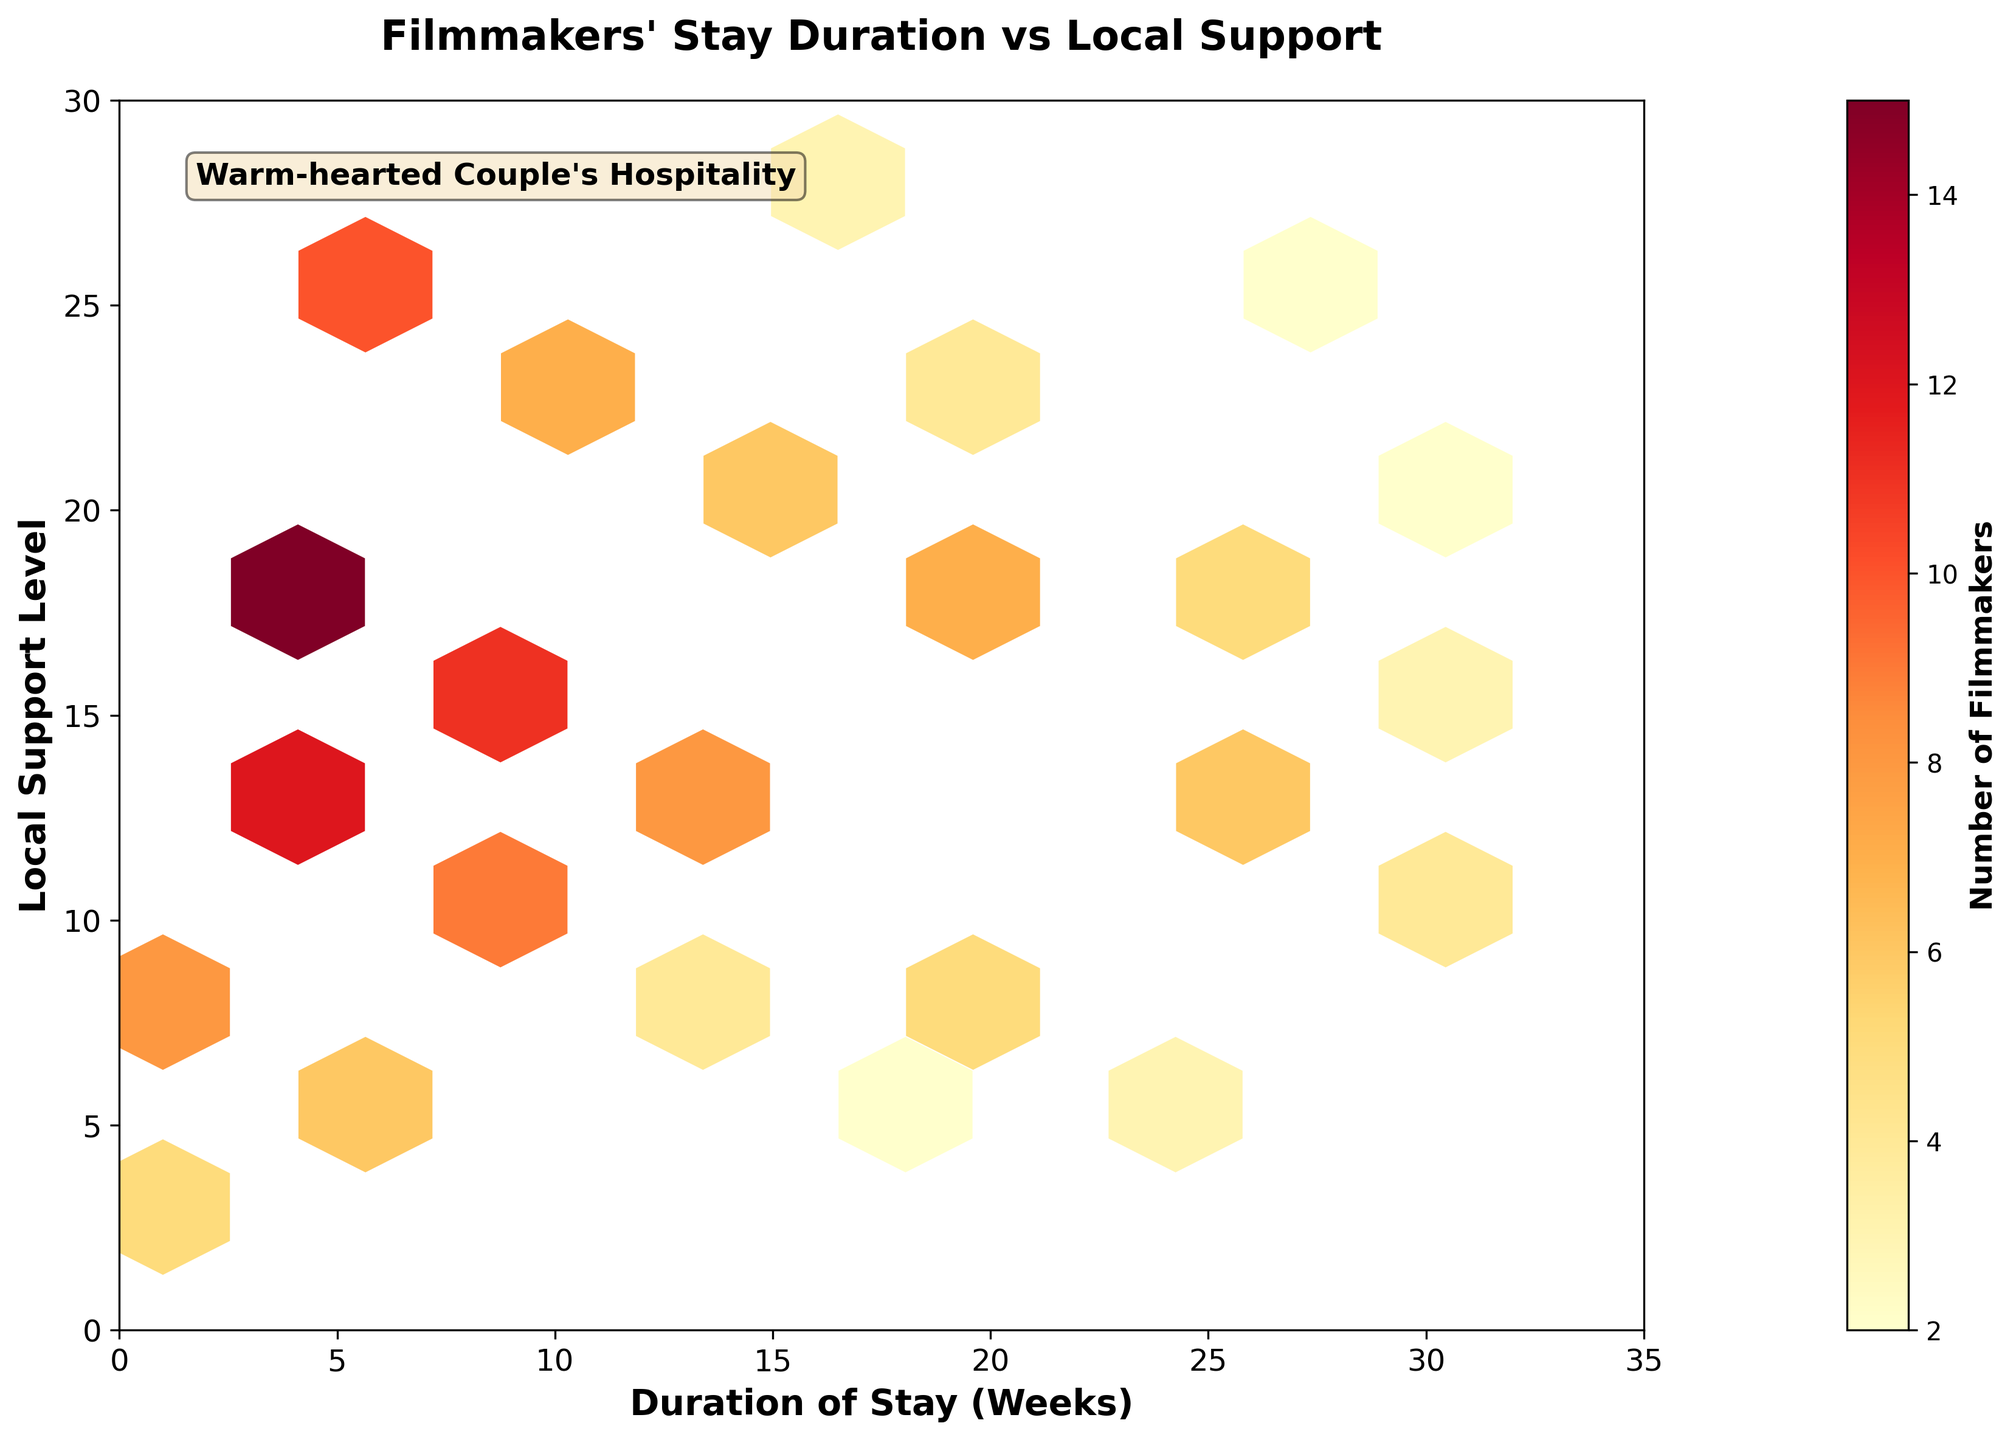What's the title of the figure? The title of the figure is written at the top of the plot. It reads "Filmmakers' Stay Duration vs Local Support".
Answer: Filmmakers' Stay Duration vs Local Support What's on the x-axis and y-axis? The x-axis label is shown as "Duration of Stay (Weeks)" and the y-axis label is shown as "Local Support Level".
Answer: Duration of Stay (Weeks) and Local Support Level Which color represents a higher number of filmmakers, yellow or red? The color bar on the right side of the plot indicates that darker red represents higher numbers of filmmakers, while lighter yellow represents lower numbers of filmmakers.
Answer: Red Where is the highest concentration of filmmakers? The darkest red hexagon represents the highest concentration, which is around x=5 (Duration of Stay in Weeks) and y=25 (Local Support Level).
Answer: Around (5, 25) How many weeks is the maximum stay duration shown on the plot? The x-axis has tick marks showing durations up to 35 weeks.
Answer: 35 weeks Which area has more local support: stays around 10 weeks or 30 weeks? By observing the y-axis and color intensities, it can be seen that stays around 10 weeks have more hexagons and a higher brightness in some, indicating higher local support levels compared to around 30 weeks.
Answer: Around 10 weeks What is the color of the hexagons around the duration of 10-15 weeks with moderate local support (around 15)? The hexagons in the area of 10-15 weeks with local support around 15 appear to be in shades of orange, indicating a moderate concentration of filmmakers.
Answer: Orange How many distinct hexagons are visible in the plot? By counting the hexagon clusters visible on the plot, there are approximately 20 distinct hexagons.
Answer: Approximately 20 Which duration of stay corresponds to the least local support level visible on the plot? The lowest local support level (y-axis) visible with a hexagon is around a duration of 18 weeks, with local support level at 4.
Answer: 18 weeks How is the color intensity of the hexagons related to the number of filmmakers? The color bar shows that hexagons with darker intensities, like dark red, signify higher numbers of filmmakers, while lighter colors like yellow indicate fewer filmmakers.
Answer: Darker means more filmmakers 